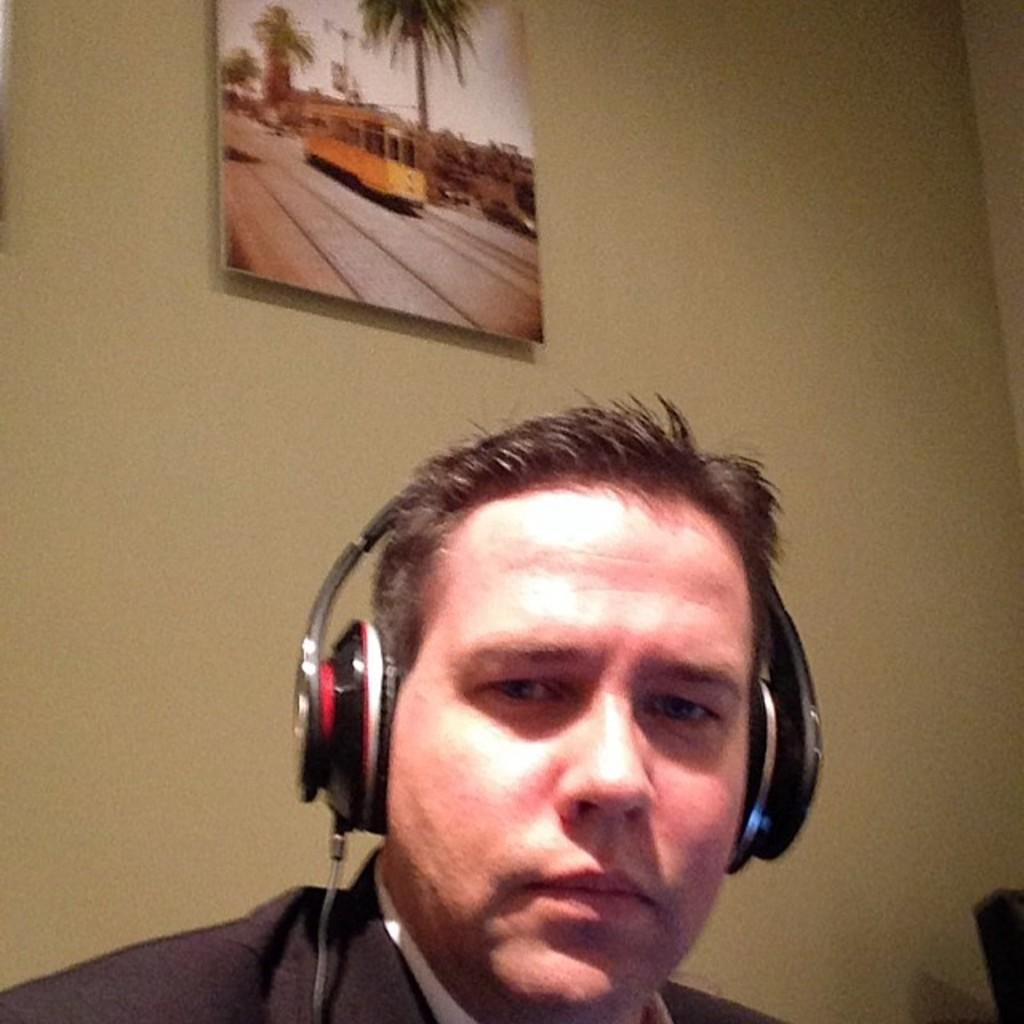Who or what is present in the image? There is a person in the image. What is the person wearing? The person is wearing headphones. What can be seen in the background of the image? There is a wall and a photo frame in the background of the image. What type of flowers are growing on the earth in the image? There are no flowers or earth present in the image; it features a person wearing headphones with a wall and a photo frame in the background. 